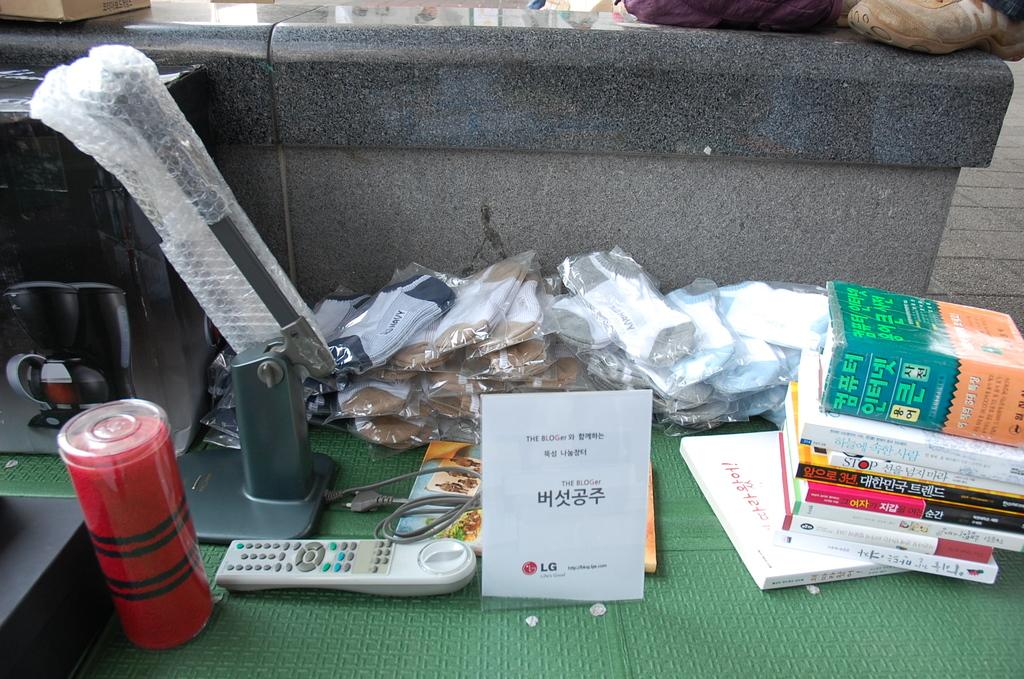<image>
Offer a succinct explanation of the picture presented. A table is full of books and other knick knacks including a sign that says, "The Bloger". 